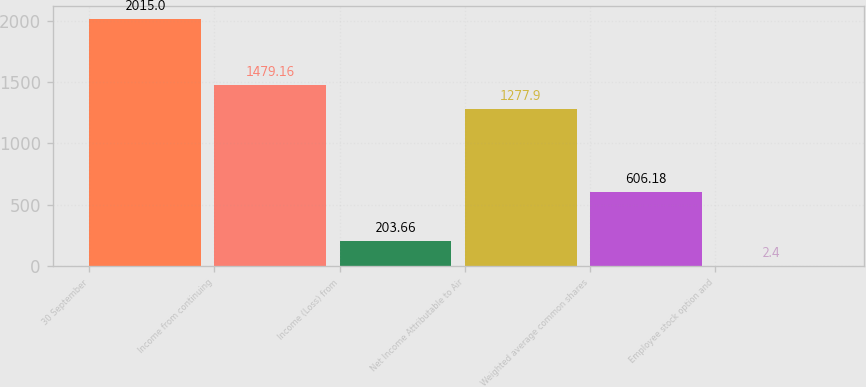Convert chart to OTSL. <chart><loc_0><loc_0><loc_500><loc_500><bar_chart><fcel>30 September<fcel>Income from continuing<fcel>Income (Loss) from<fcel>Net Income Attributable to Air<fcel>Weighted average common shares<fcel>Employee stock option and<nl><fcel>2015<fcel>1479.16<fcel>203.66<fcel>1277.9<fcel>606.18<fcel>2.4<nl></chart> 